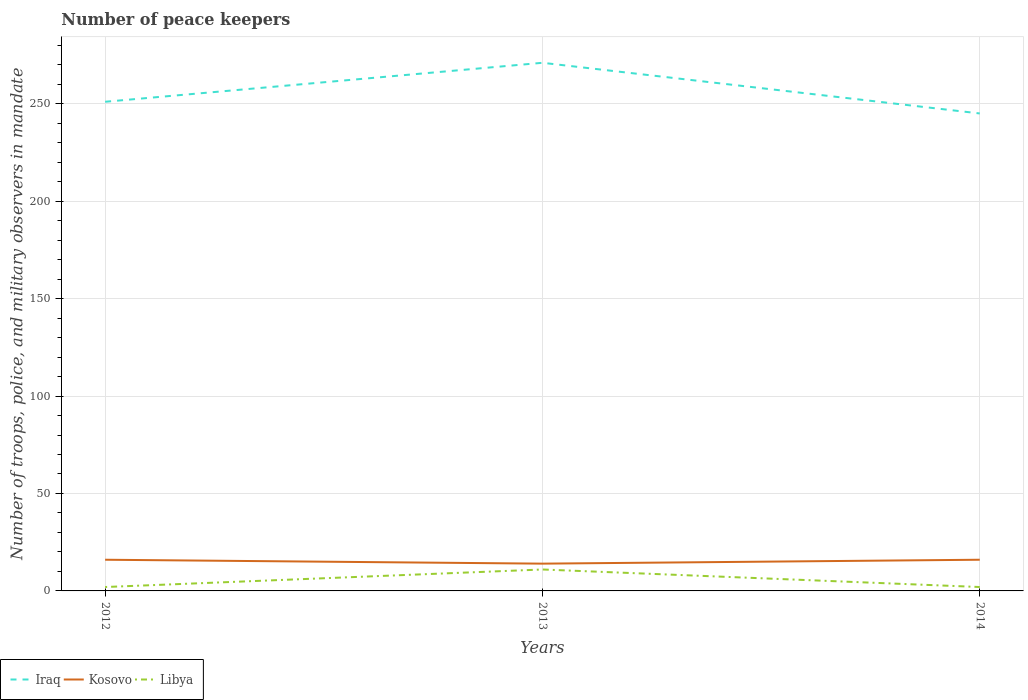How many different coloured lines are there?
Give a very brief answer. 3. Does the line corresponding to Kosovo intersect with the line corresponding to Iraq?
Keep it short and to the point. No. Is the number of lines equal to the number of legend labels?
Your answer should be very brief. Yes. Across all years, what is the maximum number of peace keepers in in Iraq?
Your answer should be very brief. 245. What is the difference between two consecutive major ticks on the Y-axis?
Provide a succinct answer. 50. Does the graph contain grids?
Provide a short and direct response. Yes. Where does the legend appear in the graph?
Offer a terse response. Bottom left. How many legend labels are there?
Provide a short and direct response. 3. How are the legend labels stacked?
Offer a terse response. Horizontal. What is the title of the graph?
Offer a terse response. Number of peace keepers. What is the label or title of the Y-axis?
Your response must be concise. Number of troops, police, and military observers in mandate. What is the Number of troops, police, and military observers in mandate in Iraq in 2012?
Offer a terse response. 251. What is the Number of troops, police, and military observers in mandate of Libya in 2012?
Your answer should be very brief. 2. What is the Number of troops, police, and military observers in mandate of Iraq in 2013?
Provide a succinct answer. 271. What is the Number of troops, police, and military observers in mandate in Kosovo in 2013?
Offer a very short reply. 14. What is the Number of troops, police, and military observers in mandate of Iraq in 2014?
Offer a very short reply. 245. What is the Number of troops, police, and military observers in mandate of Libya in 2014?
Make the answer very short. 2. Across all years, what is the maximum Number of troops, police, and military observers in mandate of Iraq?
Offer a terse response. 271. Across all years, what is the maximum Number of troops, police, and military observers in mandate of Libya?
Offer a very short reply. 11. Across all years, what is the minimum Number of troops, police, and military observers in mandate of Iraq?
Offer a very short reply. 245. What is the total Number of troops, police, and military observers in mandate in Iraq in the graph?
Ensure brevity in your answer.  767. What is the total Number of troops, police, and military observers in mandate of Kosovo in the graph?
Offer a very short reply. 46. What is the total Number of troops, police, and military observers in mandate in Libya in the graph?
Offer a terse response. 15. What is the difference between the Number of troops, police, and military observers in mandate in Iraq in 2012 and that in 2013?
Your response must be concise. -20. What is the difference between the Number of troops, police, and military observers in mandate of Kosovo in 2012 and that in 2014?
Offer a terse response. 0. What is the difference between the Number of troops, police, and military observers in mandate of Iraq in 2012 and the Number of troops, police, and military observers in mandate of Kosovo in 2013?
Offer a very short reply. 237. What is the difference between the Number of troops, police, and military observers in mandate of Iraq in 2012 and the Number of troops, police, and military observers in mandate of Libya in 2013?
Your answer should be compact. 240. What is the difference between the Number of troops, police, and military observers in mandate in Kosovo in 2012 and the Number of troops, police, and military observers in mandate in Libya in 2013?
Make the answer very short. 5. What is the difference between the Number of troops, police, and military observers in mandate in Iraq in 2012 and the Number of troops, police, and military observers in mandate in Kosovo in 2014?
Make the answer very short. 235. What is the difference between the Number of troops, police, and military observers in mandate in Iraq in 2012 and the Number of troops, police, and military observers in mandate in Libya in 2014?
Give a very brief answer. 249. What is the difference between the Number of troops, police, and military observers in mandate of Kosovo in 2012 and the Number of troops, police, and military observers in mandate of Libya in 2014?
Your answer should be very brief. 14. What is the difference between the Number of troops, police, and military observers in mandate of Iraq in 2013 and the Number of troops, police, and military observers in mandate of Kosovo in 2014?
Your answer should be compact. 255. What is the difference between the Number of troops, police, and military observers in mandate in Iraq in 2013 and the Number of troops, police, and military observers in mandate in Libya in 2014?
Make the answer very short. 269. What is the difference between the Number of troops, police, and military observers in mandate of Kosovo in 2013 and the Number of troops, police, and military observers in mandate of Libya in 2014?
Provide a succinct answer. 12. What is the average Number of troops, police, and military observers in mandate in Iraq per year?
Your response must be concise. 255.67. What is the average Number of troops, police, and military observers in mandate of Kosovo per year?
Keep it short and to the point. 15.33. In the year 2012, what is the difference between the Number of troops, police, and military observers in mandate of Iraq and Number of troops, police, and military observers in mandate of Kosovo?
Your answer should be very brief. 235. In the year 2012, what is the difference between the Number of troops, police, and military observers in mandate in Iraq and Number of troops, police, and military observers in mandate in Libya?
Your answer should be very brief. 249. In the year 2013, what is the difference between the Number of troops, police, and military observers in mandate in Iraq and Number of troops, police, and military observers in mandate in Kosovo?
Give a very brief answer. 257. In the year 2013, what is the difference between the Number of troops, police, and military observers in mandate of Iraq and Number of troops, police, and military observers in mandate of Libya?
Your answer should be very brief. 260. In the year 2014, what is the difference between the Number of troops, police, and military observers in mandate in Iraq and Number of troops, police, and military observers in mandate in Kosovo?
Ensure brevity in your answer.  229. In the year 2014, what is the difference between the Number of troops, police, and military observers in mandate in Iraq and Number of troops, police, and military observers in mandate in Libya?
Give a very brief answer. 243. In the year 2014, what is the difference between the Number of troops, police, and military observers in mandate in Kosovo and Number of troops, police, and military observers in mandate in Libya?
Offer a terse response. 14. What is the ratio of the Number of troops, police, and military observers in mandate in Iraq in 2012 to that in 2013?
Your answer should be compact. 0.93. What is the ratio of the Number of troops, police, and military observers in mandate of Kosovo in 2012 to that in 2013?
Keep it short and to the point. 1.14. What is the ratio of the Number of troops, police, and military observers in mandate in Libya in 2012 to that in 2013?
Keep it short and to the point. 0.18. What is the ratio of the Number of troops, police, and military observers in mandate in Iraq in 2012 to that in 2014?
Your answer should be very brief. 1.02. What is the ratio of the Number of troops, police, and military observers in mandate in Libya in 2012 to that in 2014?
Your response must be concise. 1. What is the ratio of the Number of troops, police, and military observers in mandate in Iraq in 2013 to that in 2014?
Provide a short and direct response. 1.11. What is the ratio of the Number of troops, police, and military observers in mandate of Kosovo in 2013 to that in 2014?
Offer a terse response. 0.88. What is the ratio of the Number of troops, police, and military observers in mandate of Libya in 2013 to that in 2014?
Your answer should be very brief. 5.5. What is the difference between the highest and the lowest Number of troops, police, and military observers in mandate of Kosovo?
Offer a very short reply. 2. What is the difference between the highest and the lowest Number of troops, police, and military observers in mandate of Libya?
Your response must be concise. 9. 